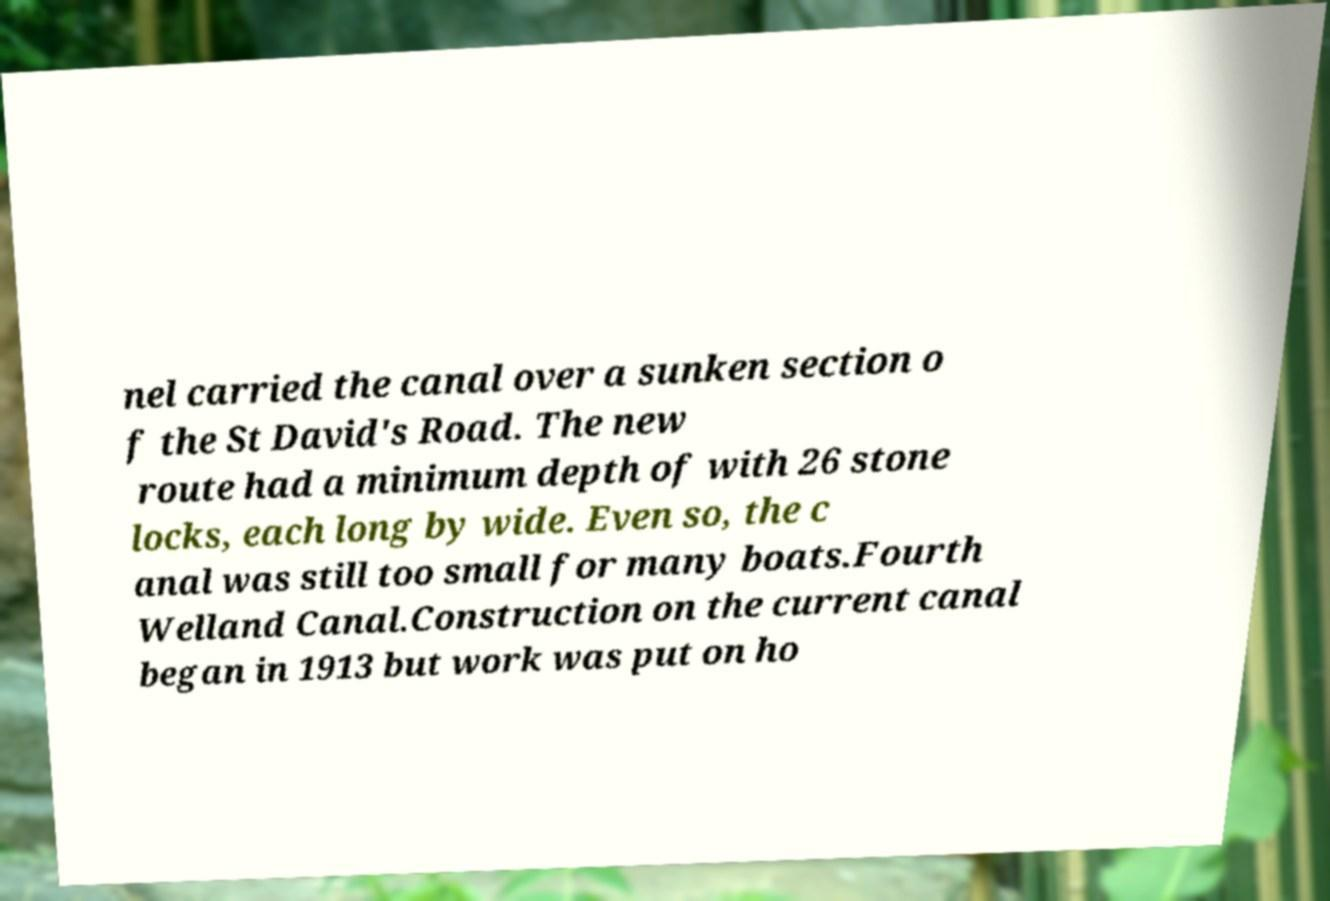Please read and relay the text visible in this image. What does it say? nel carried the canal over a sunken section o f the St David's Road. The new route had a minimum depth of with 26 stone locks, each long by wide. Even so, the c anal was still too small for many boats.Fourth Welland Canal.Construction on the current canal began in 1913 but work was put on ho 